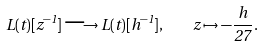<formula> <loc_0><loc_0><loc_500><loc_500>L ( t ) [ z ^ { - 1 } ] \longrightarrow L ( t ) [ h ^ { - 1 } ] , \quad z \mapsto - \frac { h } { 2 7 } .</formula> 